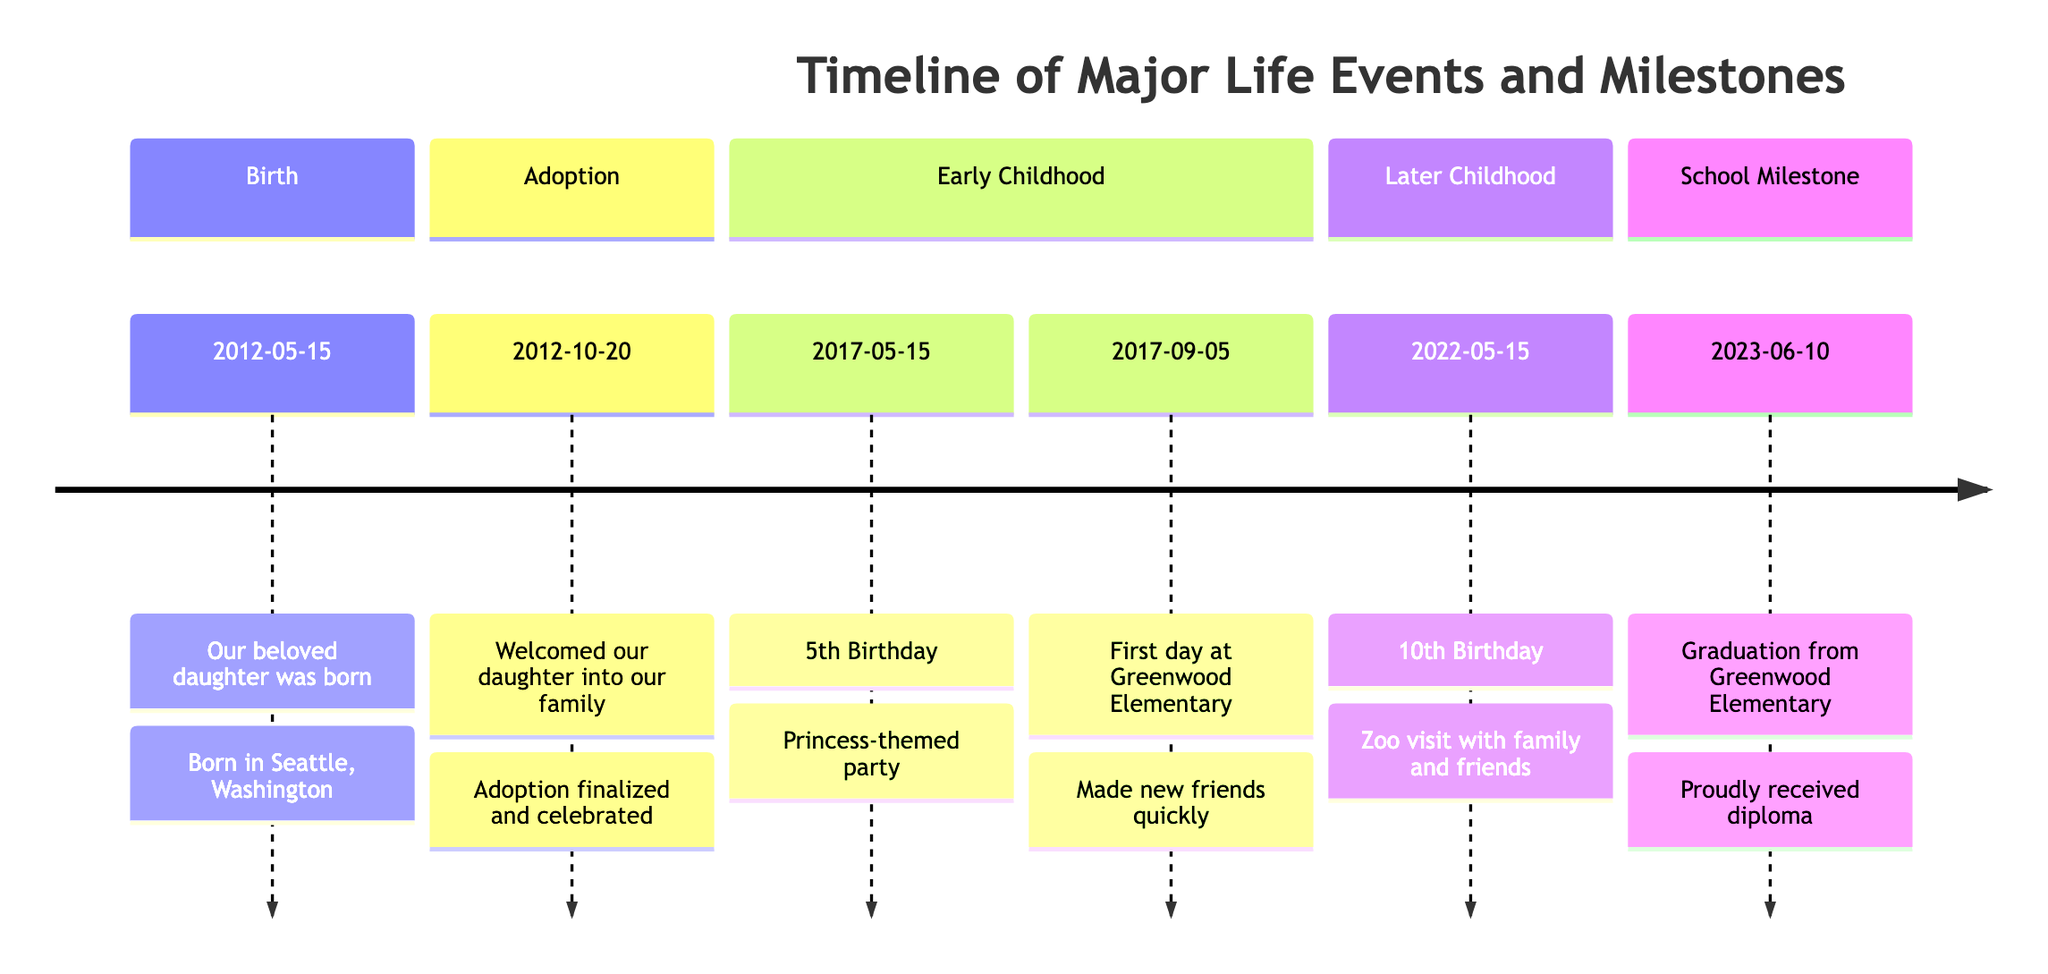What event took place on October 20, 2012? According to the timeline, the event on this date is "Adoption Day." It signifies the day when our daughter was officially welcomed into the family.
Answer: Adoption Day How many significant birthdays are noted in the timeline? The timeline mentions two significant birthdays: the 5th birthday and the 10th birthday. Therefore, the number of significant birthdays is two.
Answer: 2 What school did she attend on her first school day? For her first school day, she attended "Greenwood Elementary School," as specified in the details.
Answer: Greenwood Elementary School What was the description of the event on June 10, 2023? The event on this date, "Graduation," is described as her graduation from "Greenwood Elementary School" where she proudly received her diploma.
Answer: Graduation from Greenwood Elementary School Which milestone event occurred right after her 5th birthday? The event right after the 5th birthday is her "First School Day," which took place on September 5, 2017.
Answer: First School Day What year did she celebrate her 10th birthday? The timeline states that her 10th birthday was celebrated in the year "2022."
Answer: 2022 What was the theme of her 5th birthday party? According to the details in the timeline, her 5th birthday party had a "princess-themed" celebration.
Answer: Princess-themed party What is the date of her birth? The timeline indicates that her birth date is May 15, 2012.
Answer: May 15, 2012 What did she do on her 10th birthday? On her 10th birthday, the timeline states she visited the "Woodland Park Zoo" with family and friends, making it a special celebration.
Answer: Visited Woodland Park Zoo 